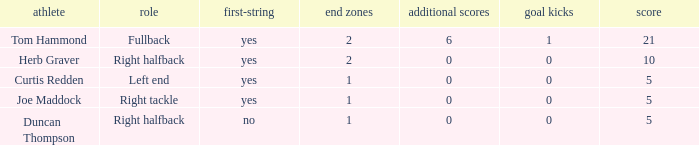Name the most extra points for right tackle 0.0. 